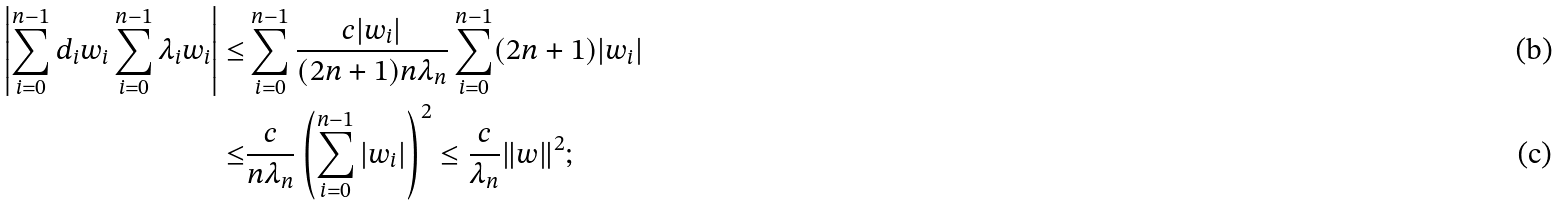<formula> <loc_0><loc_0><loc_500><loc_500>\left | \sum _ { i = 0 } ^ { n - 1 } d _ { i } w _ { i } \sum _ { i = 0 } ^ { n - 1 } \lambda _ { i } w _ { i } \right | \leq & \sum _ { i = 0 } ^ { n - 1 } \frac { c | w _ { i } | } { ( 2 n + 1 ) n \lambda _ { n } } \sum _ { i = 0 } ^ { n - 1 } ( 2 n + 1 ) | w _ { i } | \\ \leq & \frac { c } { n \lambda _ { n } } \left ( \sum _ { i = 0 } ^ { n - 1 } | w _ { i } | \right ) ^ { 2 } \leq \frac { c } { \lambda _ { n } } \| w \| ^ { 2 } ;</formula> 